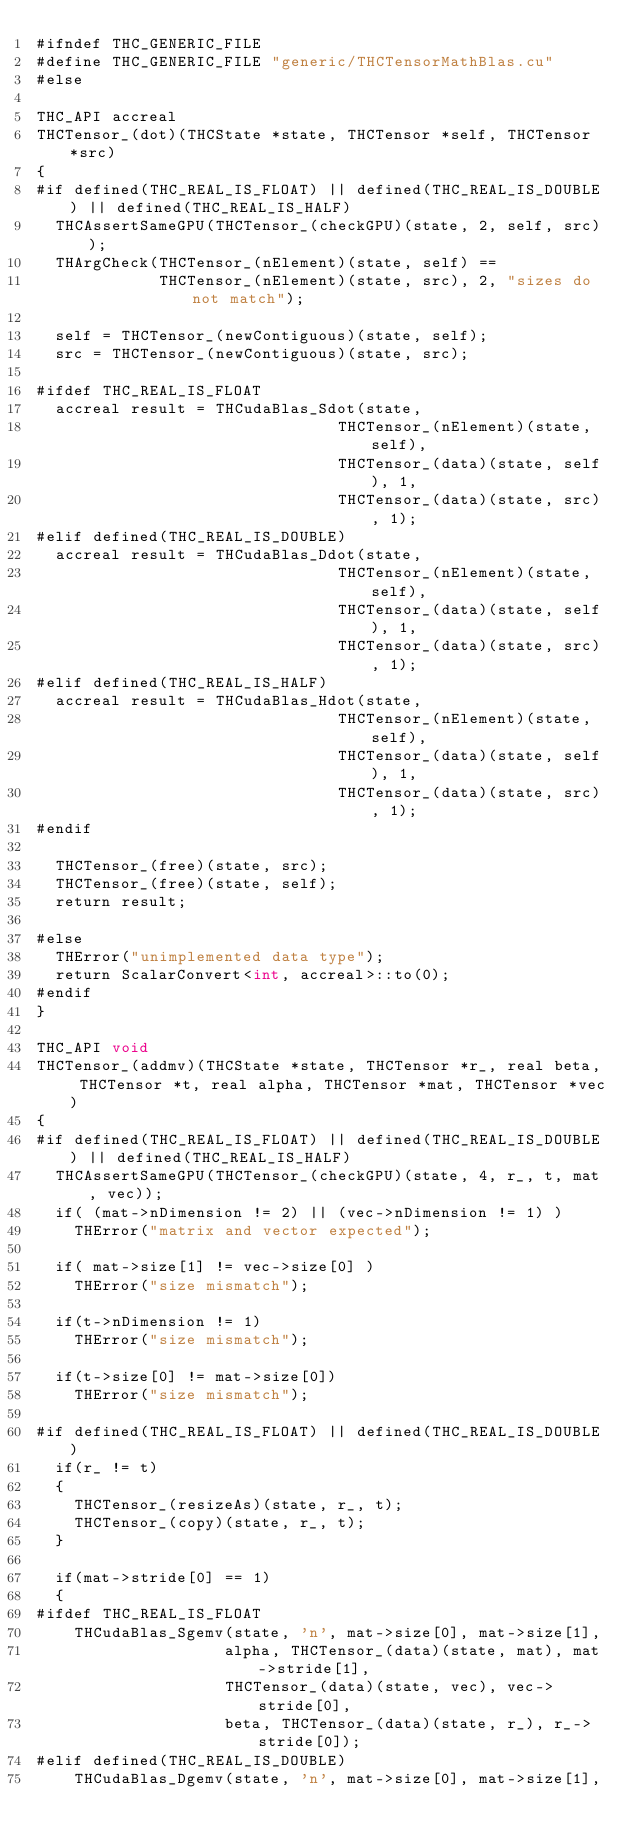Convert code to text. <code><loc_0><loc_0><loc_500><loc_500><_Cuda_>#ifndef THC_GENERIC_FILE
#define THC_GENERIC_FILE "generic/THCTensorMathBlas.cu"
#else

THC_API accreal
THCTensor_(dot)(THCState *state, THCTensor *self, THCTensor *src)
{
#if defined(THC_REAL_IS_FLOAT) || defined(THC_REAL_IS_DOUBLE) || defined(THC_REAL_IS_HALF)
  THCAssertSameGPU(THCTensor_(checkGPU)(state, 2, self, src));
  THArgCheck(THCTensor_(nElement)(state, self) ==
             THCTensor_(nElement)(state, src), 2, "sizes do not match");

  self = THCTensor_(newContiguous)(state, self);
  src = THCTensor_(newContiguous)(state, src);

#ifdef THC_REAL_IS_FLOAT
  accreal result = THCudaBlas_Sdot(state,
                                THCTensor_(nElement)(state, self),
                                THCTensor_(data)(state, self), 1,
                                THCTensor_(data)(state, src), 1);
#elif defined(THC_REAL_IS_DOUBLE)
  accreal result = THCudaBlas_Ddot(state,
                                THCTensor_(nElement)(state, self),
                                THCTensor_(data)(state, self), 1,
                                THCTensor_(data)(state, src), 1);
#elif defined(THC_REAL_IS_HALF)
  accreal result = THCudaBlas_Hdot(state,
                                THCTensor_(nElement)(state, self),
                                THCTensor_(data)(state, self), 1,
                                THCTensor_(data)(state, src), 1);
#endif

  THCTensor_(free)(state, src);
  THCTensor_(free)(state, self);
  return result;

#else
  THError("unimplemented data type");
  return ScalarConvert<int, accreal>::to(0);
#endif
}

THC_API void
THCTensor_(addmv)(THCState *state, THCTensor *r_, real beta, THCTensor *t, real alpha, THCTensor *mat, THCTensor *vec)
{
#if defined(THC_REAL_IS_FLOAT) || defined(THC_REAL_IS_DOUBLE) || defined(THC_REAL_IS_HALF)
  THCAssertSameGPU(THCTensor_(checkGPU)(state, 4, r_, t, mat, vec));
  if( (mat->nDimension != 2) || (vec->nDimension != 1) )
    THError("matrix and vector expected");

  if( mat->size[1] != vec->size[0] )
    THError("size mismatch");

  if(t->nDimension != 1)
    THError("size mismatch");

  if(t->size[0] != mat->size[0])
    THError("size mismatch");

#if defined(THC_REAL_IS_FLOAT) || defined(THC_REAL_IS_DOUBLE)
  if(r_ != t)
  {
    THCTensor_(resizeAs)(state, r_, t);
    THCTensor_(copy)(state, r_, t);
  }

  if(mat->stride[0] == 1)
  {
#ifdef THC_REAL_IS_FLOAT
    THCudaBlas_Sgemv(state, 'n', mat->size[0], mat->size[1],
                    alpha, THCTensor_(data)(state, mat), mat->stride[1],
                    THCTensor_(data)(state, vec), vec->stride[0],
                    beta, THCTensor_(data)(state, r_), r_->stride[0]);
#elif defined(THC_REAL_IS_DOUBLE)
    THCudaBlas_Dgemv(state, 'n', mat->size[0], mat->size[1],</code> 